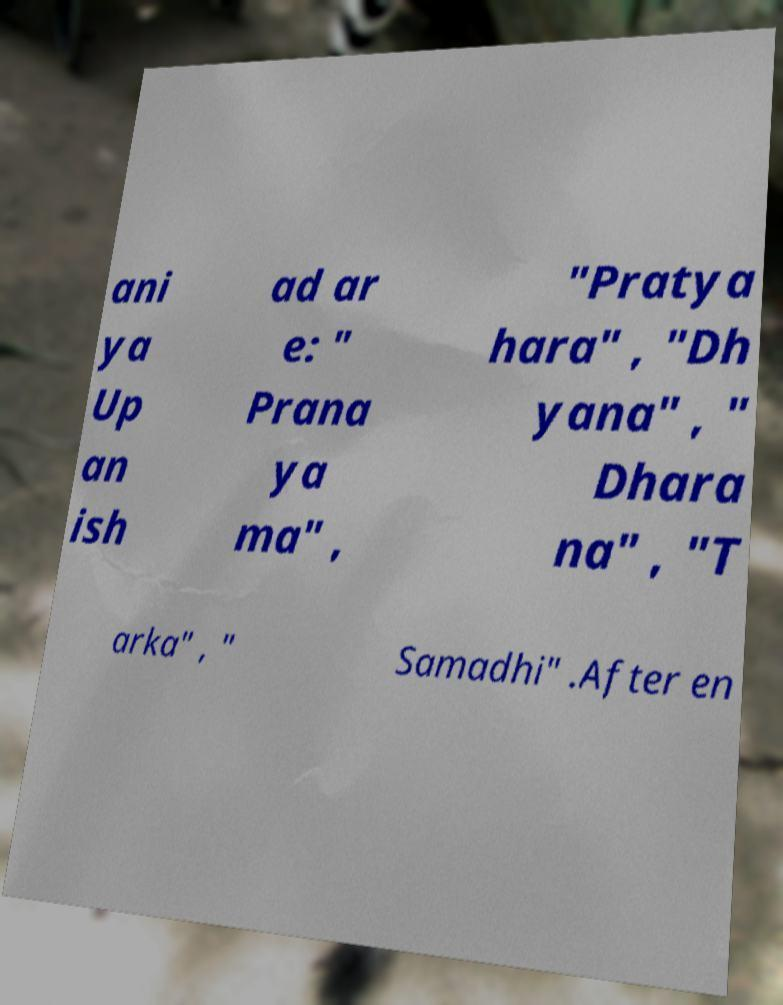What messages or text are displayed in this image? I need them in a readable, typed format. ani ya Up an ish ad ar e: " Prana ya ma" , "Pratya hara" , "Dh yana" , " Dhara na" , "T arka" , " Samadhi" .After en 